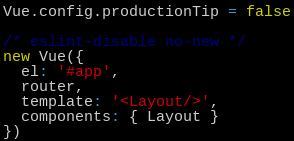<code> <loc_0><loc_0><loc_500><loc_500><_JavaScript_>Vue.config.productionTip = false

/* eslint-disable no-new */
new Vue({
  el: '#app',
  router,
  template: '<Layout/>',
  components: { Layout }
})
</code> 